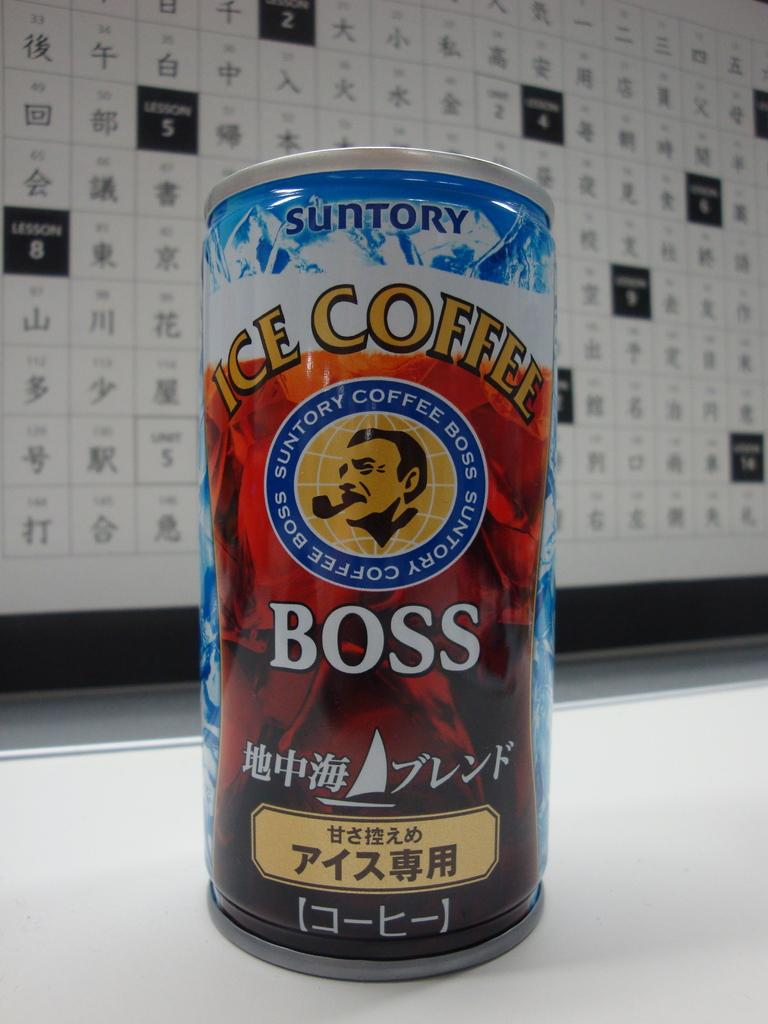<image>
Offer a succinct explanation of the picture presented. A can of iced coffee called Boss sitting in front of a board of Japanese letters. 